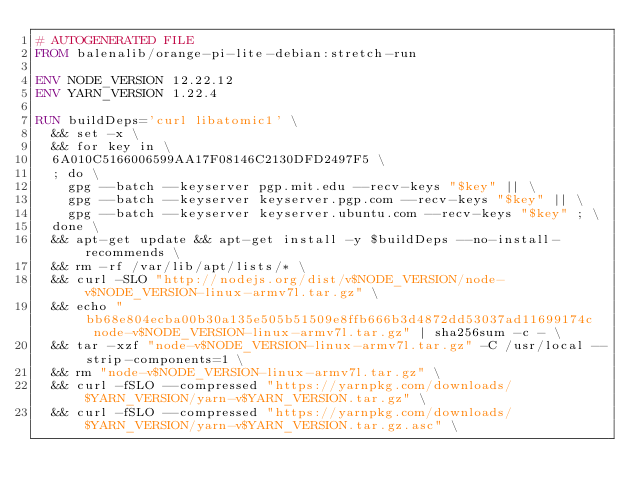Convert code to text. <code><loc_0><loc_0><loc_500><loc_500><_Dockerfile_># AUTOGENERATED FILE
FROM balenalib/orange-pi-lite-debian:stretch-run

ENV NODE_VERSION 12.22.12
ENV YARN_VERSION 1.22.4

RUN buildDeps='curl libatomic1' \
	&& set -x \
	&& for key in \
	6A010C5166006599AA17F08146C2130DFD2497F5 \
	; do \
		gpg --batch --keyserver pgp.mit.edu --recv-keys "$key" || \
		gpg --batch --keyserver keyserver.pgp.com --recv-keys "$key" || \
		gpg --batch --keyserver keyserver.ubuntu.com --recv-keys "$key" ; \
	done \
	&& apt-get update && apt-get install -y $buildDeps --no-install-recommends \
	&& rm -rf /var/lib/apt/lists/* \
	&& curl -SLO "http://nodejs.org/dist/v$NODE_VERSION/node-v$NODE_VERSION-linux-armv7l.tar.gz" \
	&& echo "bb68e804ecba00b30a135e505b51509e8ffb666b3d4872dd53037ad11699174c  node-v$NODE_VERSION-linux-armv7l.tar.gz" | sha256sum -c - \
	&& tar -xzf "node-v$NODE_VERSION-linux-armv7l.tar.gz" -C /usr/local --strip-components=1 \
	&& rm "node-v$NODE_VERSION-linux-armv7l.tar.gz" \
	&& curl -fSLO --compressed "https://yarnpkg.com/downloads/$YARN_VERSION/yarn-v$YARN_VERSION.tar.gz" \
	&& curl -fSLO --compressed "https://yarnpkg.com/downloads/$YARN_VERSION/yarn-v$YARN_VERSION.tar.gz.asc" \</code> 